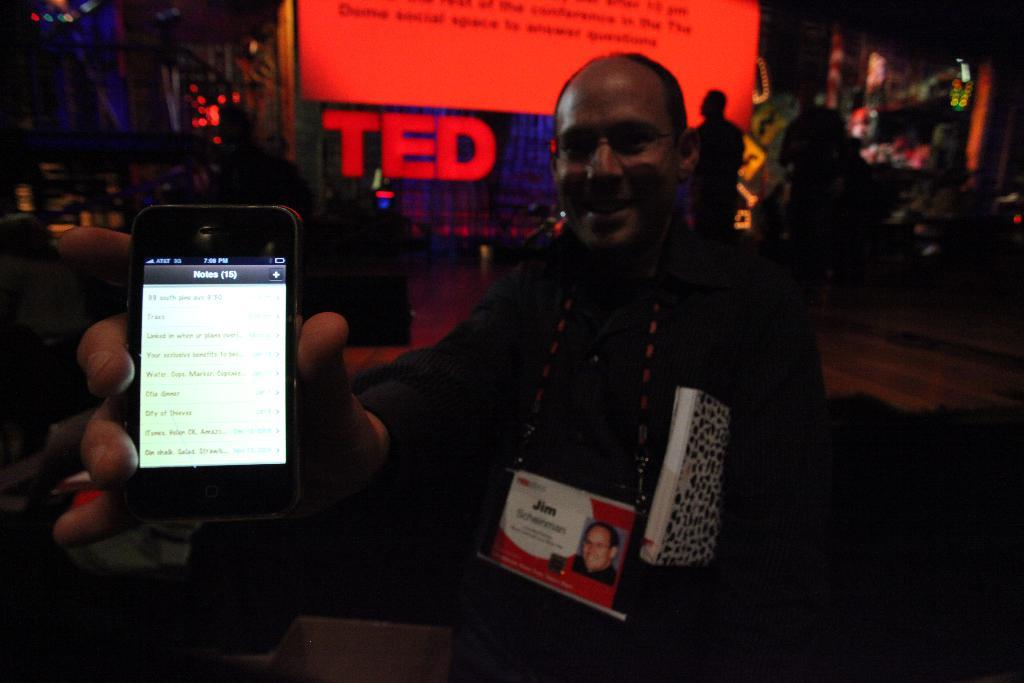<image>
Provide a brief description of the given image. a man in front of a large Ted talk sign 